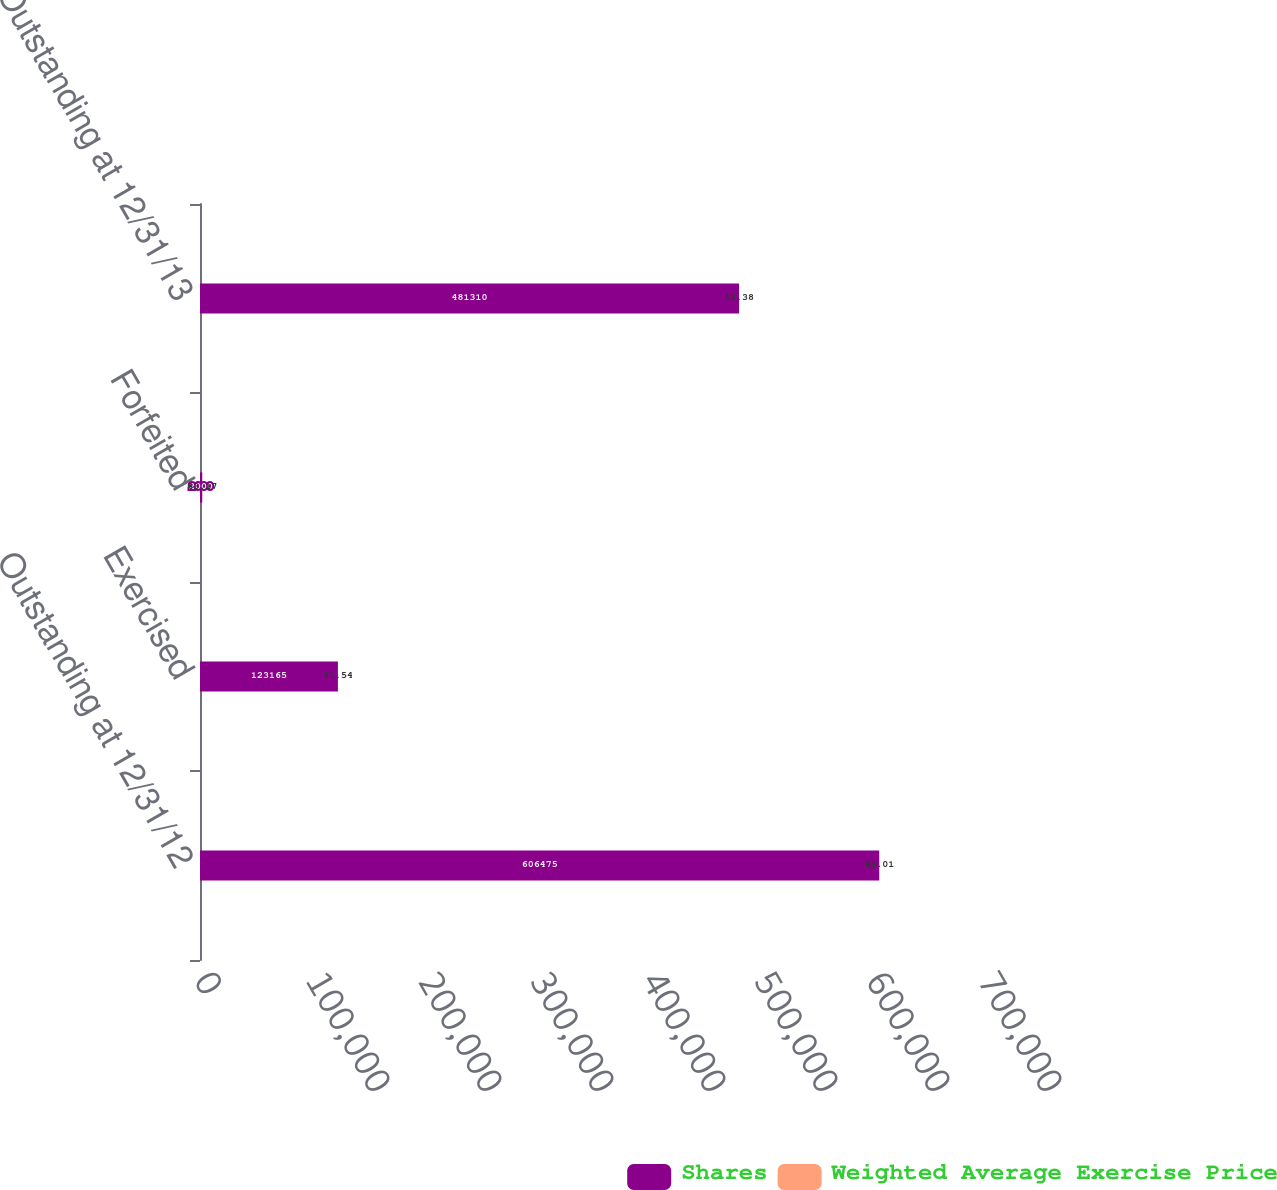<chart> <loc_0><loc_0><loc_500><loc_500><stacked_bar_chart><ecel><fcel>Outstanding at 12/31/12<fcel>Exercised<fcel>Forfeited<fcel>Outstanding at 12/31/13<nl><fcel>Shares<fcel>606475<fcel>123165<fcel>2000<fcel>481310<nl><fcel>Weighted Average Exercise Price<fcel>43.01<fcel>41.54<fcel>43.17<fcel>43.38<nl></chart> 